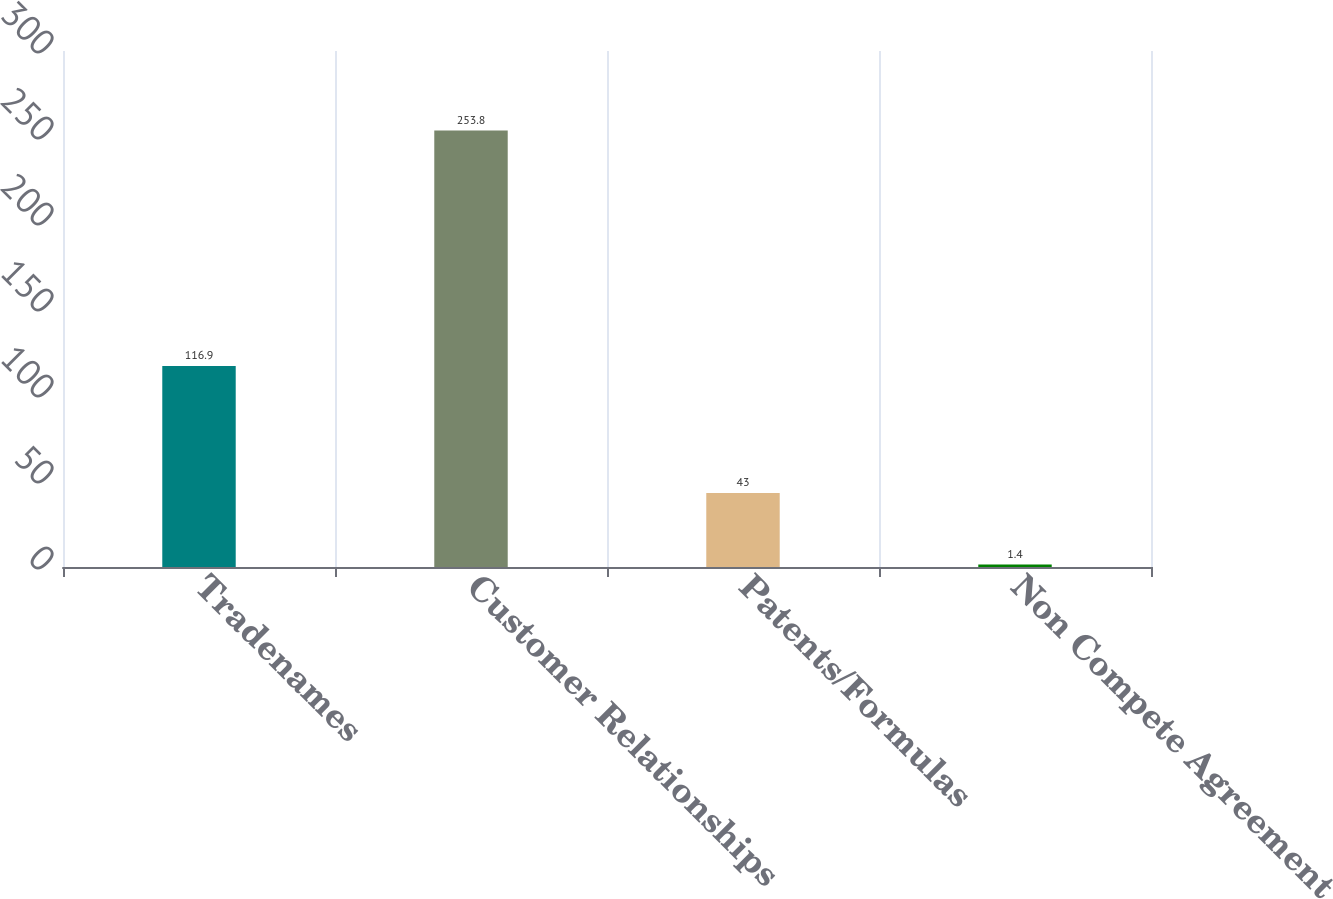Convert chart to OTSL. <chart><loc_0><loc_0><loc_500><loc_500><bar_chart><fcel>Tradenames<fcel>Customer Relationships<fcel>Patents/Formulas<fcel>Non Compete Agreement<nl><fcel>116.9<fcel>253.8<fcel>43<fcel>1.4<nl></chart> 